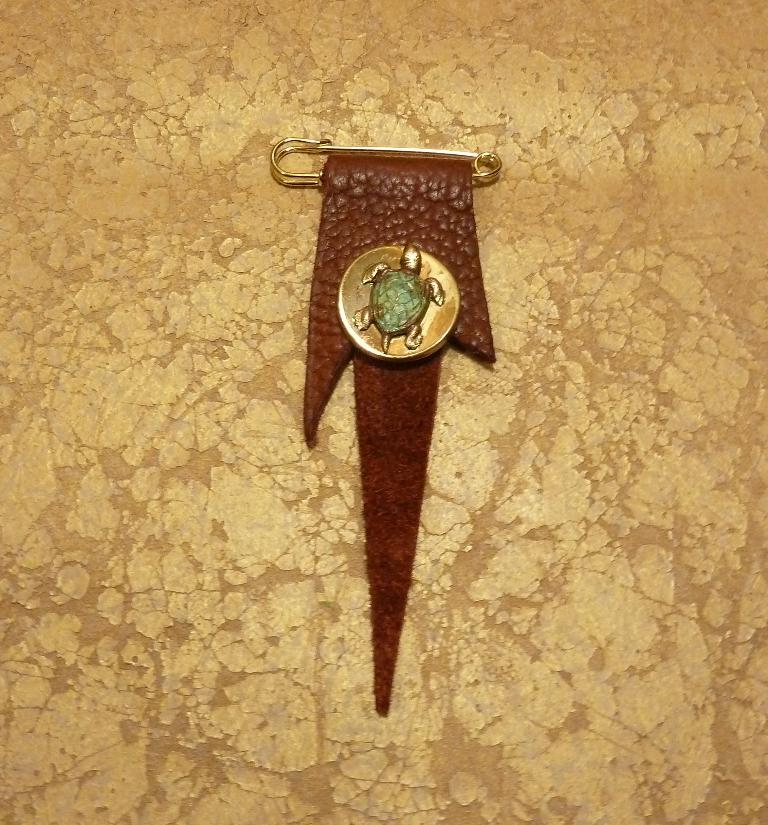What is present on the cloth in the image? There is a pin on the cloth. What is unique about the pin? The pin has a batch. What symbol is on the batch? The batch has a turtle symbol. What nation are the friends from in the image? There are no friends or nation mentioned in the image; it only features a cloth with a pin that has a batch with a turtle symbol. 